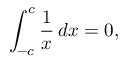<formula> <loc_0><loc_0><loc_500><loc_500>\int _ { - c } ^ { c } { \frac { 1 } { x } } \, d x = 0 ,</formula> 